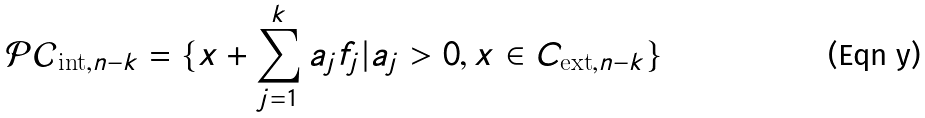Convert formula to latex. <formula><loc_0><loc_0><loc_500><loc_500>\mathcal { P C } _ { \text {int} , n - k } = \{ x + \sum _ { j = 1 } ^ { k } a _ { j } f _ { j } | a _ { j } > 0 , x \in C _ { \text {ext} , n - k } \}</formula> 